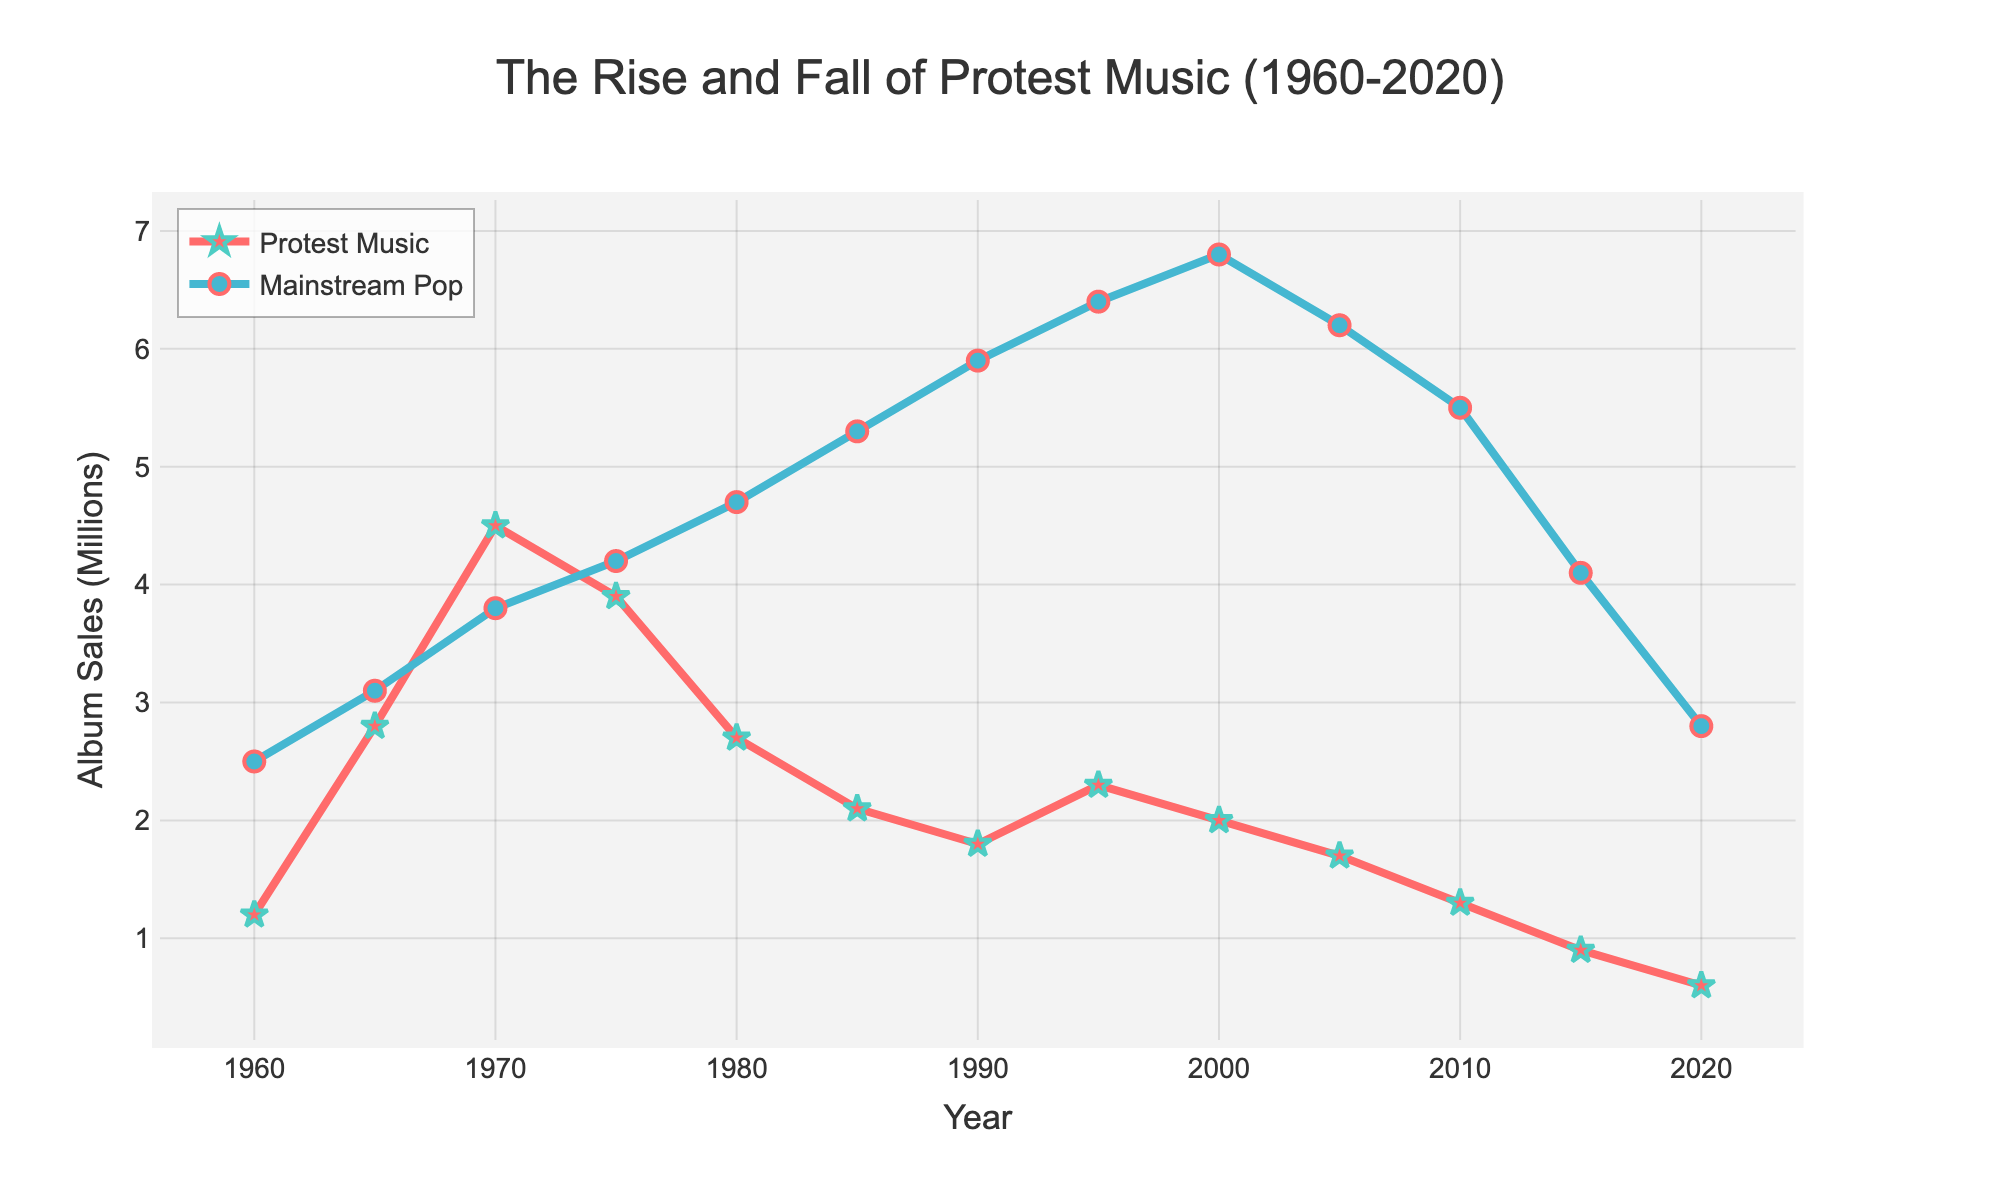what is the general trend in album sales for mainstream pop artists from 1960 to 2020? The line graph shows a general upward trend for mainstream pop artists from 1960 to around 2000, peaking around 2000-2005, and then a gradual decline toward 2020.
Answer: Upward, then downward What year had the highest album sales for protest music artists? By checking the peak point in the "Protest Music Artists" line, sales were highest around 1970.
Answer: 1970 How did the album sales of protest music artists in 1965 compare to those in 1980? Compare the points on the line. In 1965, sales were higher than in 1980: ~2.8 million compared to ~2.7 million.
Answer: Higher in 1965 During what period did protest music artists' album sales decline continuously? Look for a continuous downward trend in the "Protest Music Artists" line. This occurs from around 1975 to 2020.
Answer: 1975-2020 What is the approximate difference in album sales between protest music artists and mainstream pop artists in 1990? Look at the data points for both artists in 1990 and subtract. ~5.9 million (Pop) - ~1.8 million (Protest) = ~4.1 million.
Answer: ~4.1 million By how much did album sales for mainstream pop artists increase from 1960 to 2000? Subtract the album sales in 1960 from those in 2000: 6.8 million - 2.5 million = 4.3 million.
Answer: 4.3 million Which genre showed a sharper decline in album sales after 2000? Compare the slopes of the declines. The "Protest Music Artists" shows a sharper decline than "Mainstream Pop Artists."
Answer: Protest music How do the album sales in 2010 for both genres compare? Locate both points on the graph for 2010. Mainstream Pop is roughly 5.5 million, while Protest Music is about 1.3 million.
Answer: Pop is higher What was the overall trend in album sales for both genres between 2005 and 2020? Both lines show a decline over this period.
Answer: Declining What is the average album sales for protest music artists over the 60-year span? Sum all protest music album sales and divide by the number of data points: (1.2 + 2.8 + 4.5 + 3.9 + 2.7 + 2.1 + 1.8 + 2.3 + 2.0 + 1.7 + 1.3 + 0.9 + 0.6) / 13 ≈ 2.2.
Answer: ~2.2 million 